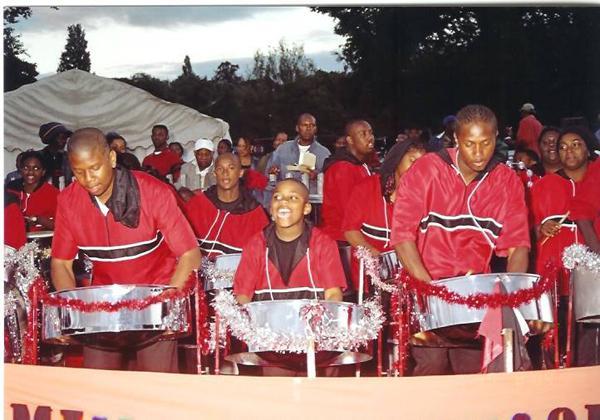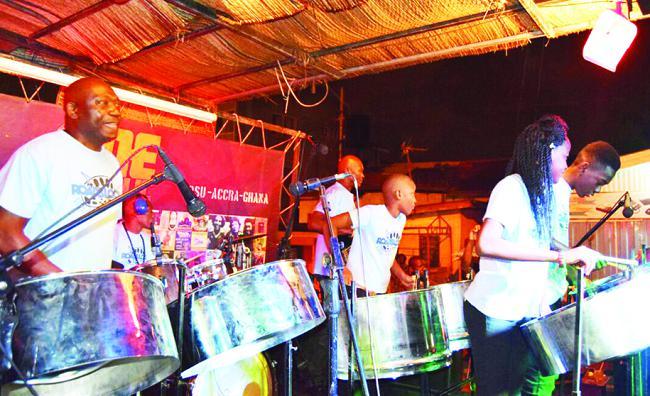The first image is the image on the left, the second image is the image on the right. Considering the images on both sides, is "The foreground of one image features a row of at least three forward-turned people in red shirts bending over silver drums." valid? Answer yes or no. Yes. The first image is the image on the left, the second image is the image on the right. Given the left and right images, does the statement "In the image to the right, people wearing white shirts are banging steel drum instruments." hold true? Answer yes or no. Yes. 